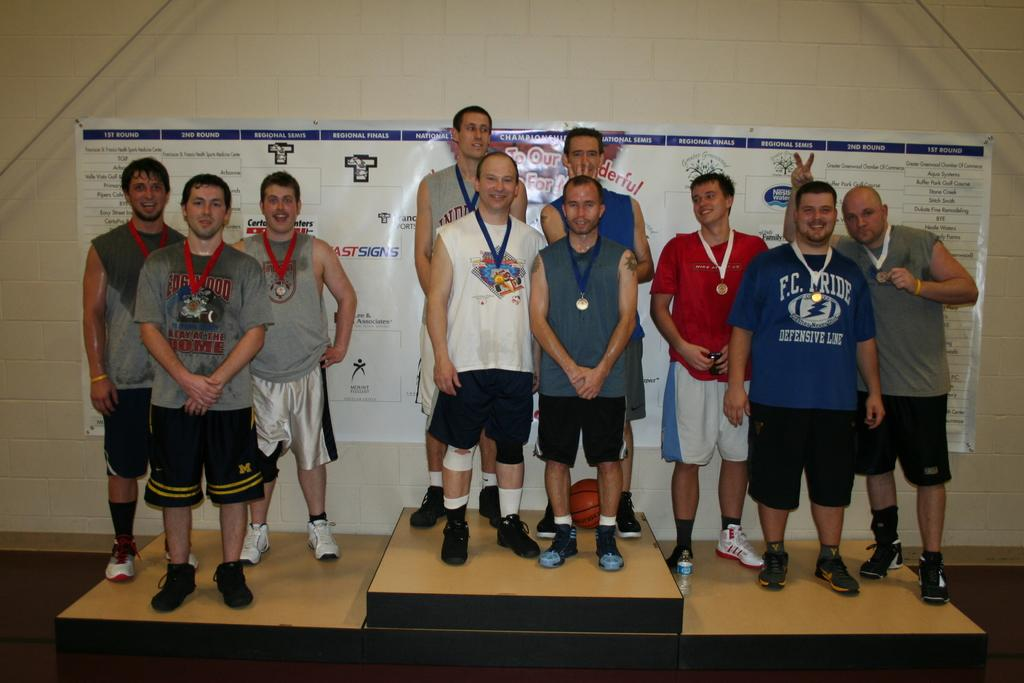How many people are in the image? There is a group of people in the image. What object is present in the image that could be used for playing? There is a ball in the image. What can be seen on the wall in the background of the image? There is a board on the wall in the background. What type of objects are present on both sides of the image? There are ropes on both the right and left sides of the image. What type of baseball play is being demonstrated in the image? There is no baseball play present in the image; it does not depict any baseball-related activities. 